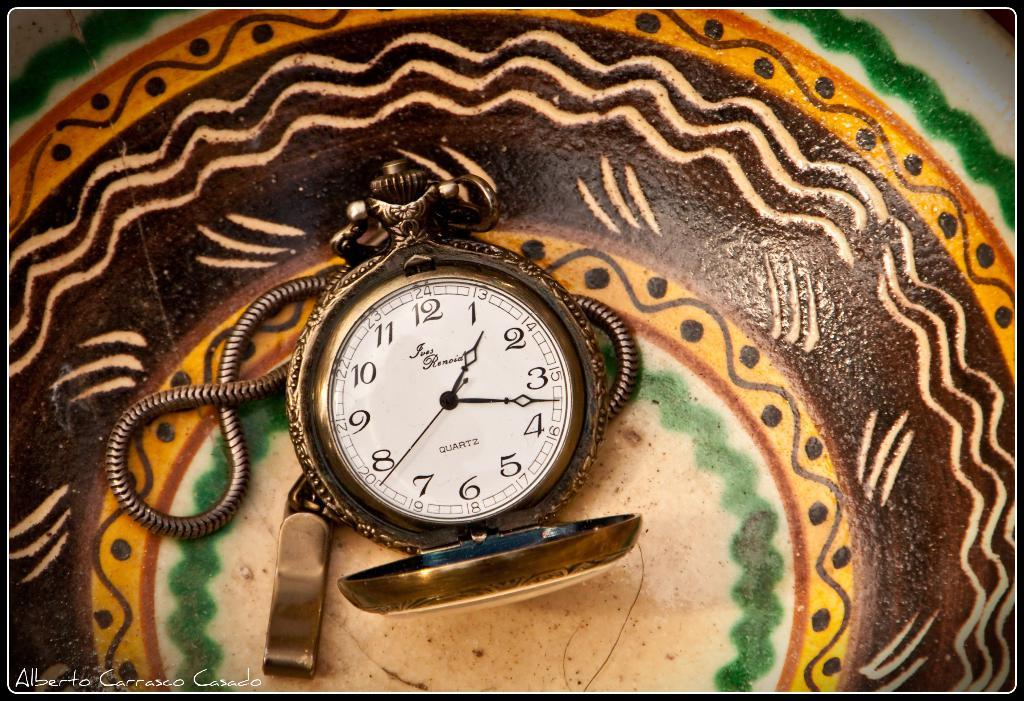<image>
Relay a brief, clear account of the picture shown. A pocket watch in a bowl has a brand name that is two words, the second word starting with an R. 